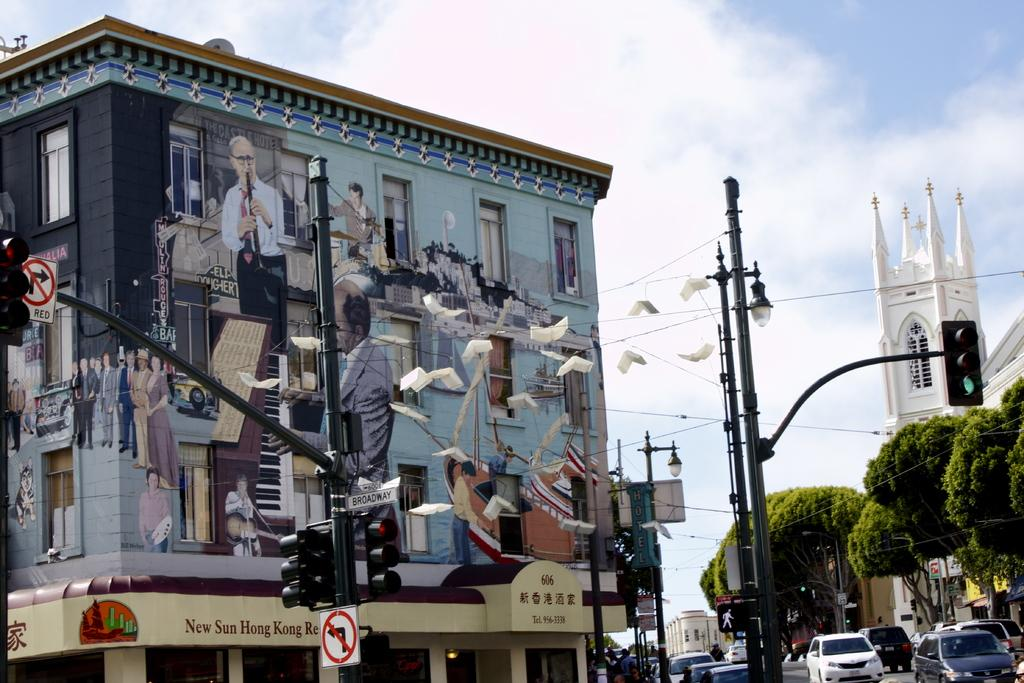What is on the pole that is visible in the image? There is a sign board on the pole in the image. What can be seen in the distance behind the pole? There are buildings and trees in the background of the image. Are there any other poles visible in the image? Yes, there are poles in the background of the image. What is happening on the road in the image? There are cars on the road in the image. How would you describe the weather in the image? The sky is cloudy in the image. Can you tell me how many bars of soap are on the sign board in the image? There are no bars of soap present on the sign board in the image. What type of sign is the pole holding in the image? The pole is holding a sign board, but the specific type of sign cannot be determined from the image. 